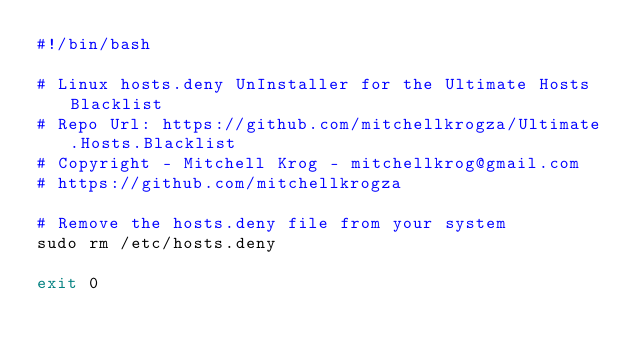Convert code to text. <code><loc_0><loc_0><loc_500><loc_500><_Bash_>#!/bin/bash

# Linux hosts.deny UnInstaller for the Ultimate Hosts Blacklist
# Repo Url: https://github.com/mitchellkrogza/Ultimate.Hosts.Blacklist
# Copyright - Mitchell Krog - mitchellkrog@gmail.com 
# https://github.com/mitchellkrogza

# Remove the hosts.deny file from your system
sudo rm /etc/hosts.deny

exit 0
</code> 